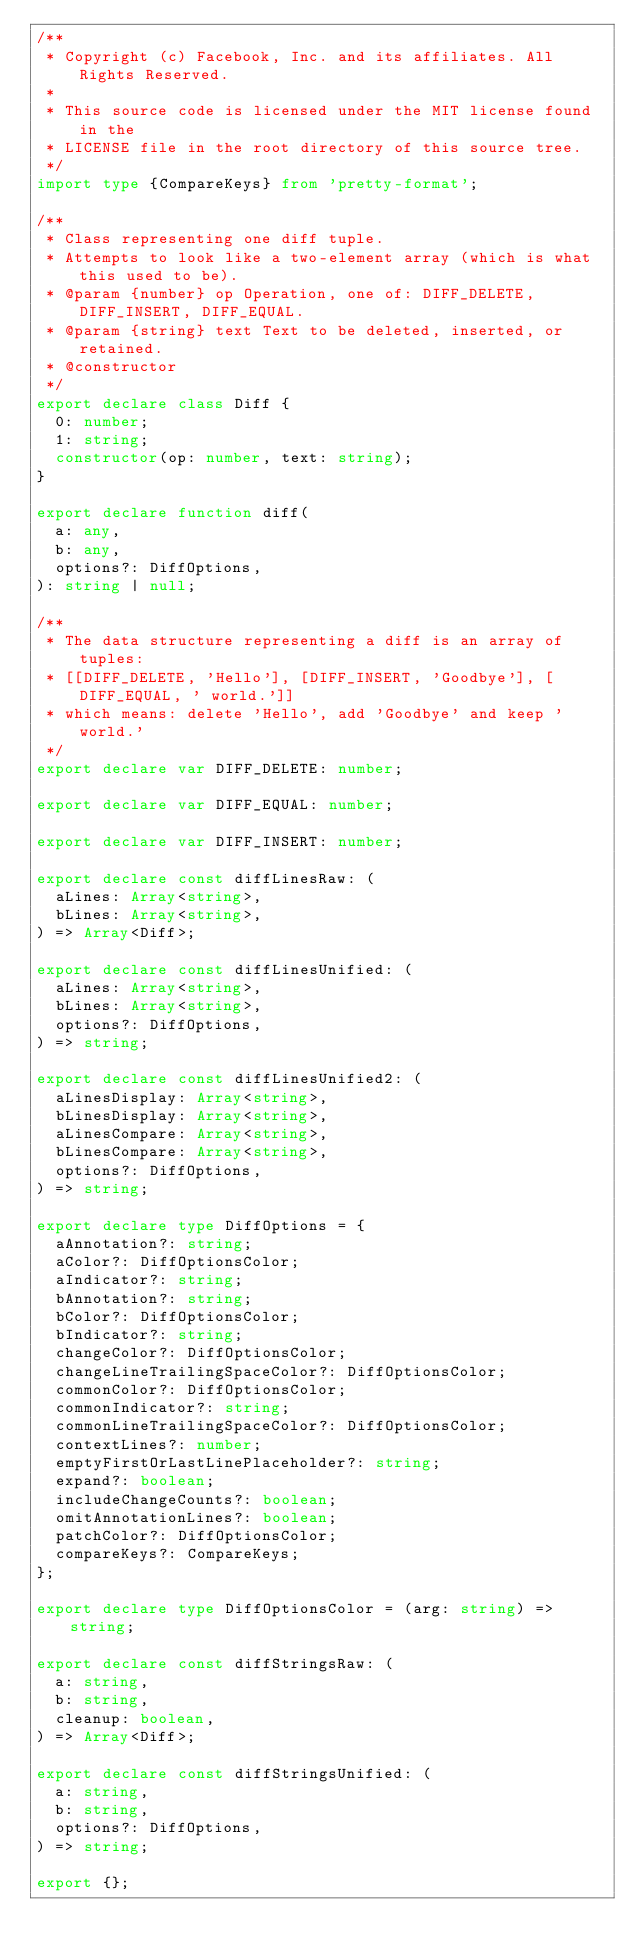Convert code to text. <code><loc_0><loc_0><loc_500><loc_500><_TypeScript_>/**
 * Copyright (c) Facebook, Inc. and its affiliates. All Rights Reserved.
 *
 * This source code is licensed under the MIT license found in the
 * LICENSE file in the root directory of this source tree.
 */
import type {CompareKeys} from 'pretty-format';

/**
 * Class representing one diff tuple.
 * Attempts to look like a two-element array (which is what this used to be).
 * @param {number} op Operation, one of: DIFF_DELETE, DIFF_INSERT, DIFF_EQUAL.
 * @param {string} text Text to be deleted, inserted, or retained.
 * @constructor
 */
export declare class Diff {
  0: number;
  1: string;
  constructor(op: number, text: string);
}

export declare function diff(
  a: any,
  b: any,
  options?: DiffOptions,
): string | null;

/**
 * The data structure representing a diff is an array of tuples:
 * [[DIFF_DELETE, 'Hello'], [DIFF_INSERT, 'Goodbye'], [DIFF_EQUAL, ' world.']]
 * which means: delete 'Hello', add 'Goodbye' and keep ' world.'
 */
export declare var DIFF_DELETE: number;

export declare var DIFF_EQUAL: number;

export declare var DIFF_INSERT: number;

export declare const diffLinesRaw: (
  aLines: Array<string>,
  bLines: Array<string>,
) => Array<Diff>;

export declare const diffLinesUnified: (
  aLines: Array<string>,
  bLines: Array<string>,
  options?: DiffOptions,
) => string;

export declare const diffLinesUnified2: (
  aLinesDisplay: Array<string>,
  bLinesDisplay: Array<string>,
  aLinesCompare: Array<string>,
  bLinesCompare: Array<string>,
  options?: DiffOptions,
) => string;

export declare type DiffOptions = {
  aAnnotation?: string;
  aColor?: DiffOptionsColor;
  aIndicator?: string;
  bAnnotation?: string;
  bColor?: DiffOptionsColor;
  bIndicator?: string;
  changeColor?: DiffOptionsColor;
  changeLineTrailingSpaceColor?: DiffOptionsColor;
  commonColor?: DiffOptionsColor;
  commonIndicator?: string;
  commonLineTrailingSpaceColor?: DiffOptionsColor;
  contextLines?: number;
  emptyFirstOrLastLinePlaceholder?: string;
  expand?: boolean;
  includeChangeCounts?: boolean;
  omitAnnotationLines?: boolean;
  patchColor?: DiffOptionsColor;
  compareKeys?: CompareKeys;
};

export declare type DiffOptionsColor = (arg: string) => string;

export declare const diffStringsRaw: (
  a: string,
  b: string,
  cleanup: boolean,
) => Array<Diff>;

export declare const diffStringsUnified: (
  a: string,
  b: string,
  options?: DiffOptions,
) => string;

export {};
</code> 